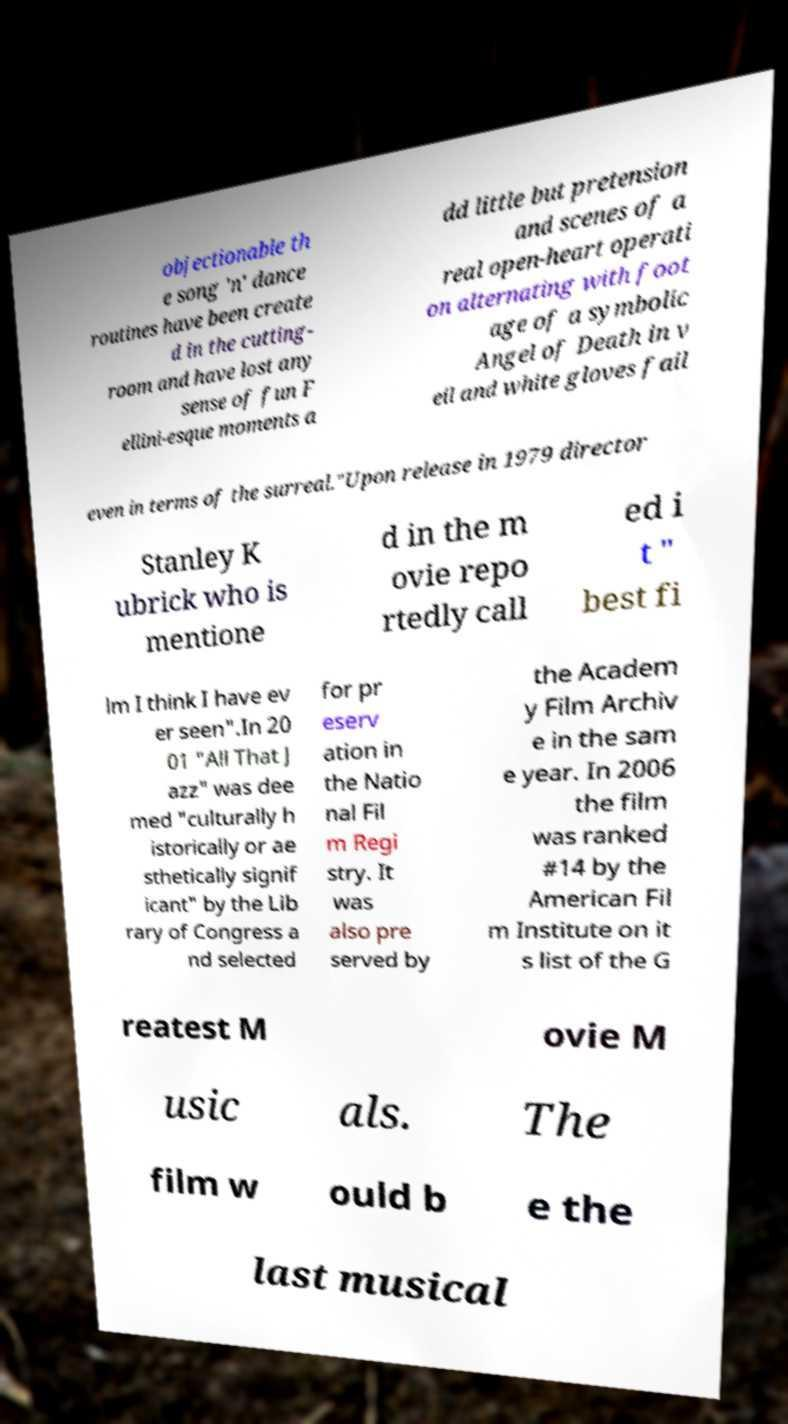Could you assist in decoding the text presented in this image and type it out clearly? objectionable th e song 'n' dance routines have been create d in the cutting- room and have lost any sense of fun F ellini-esque moments a dd little but pretension and scenes of a real open-heart operati on alternating with foot age of a symbolic Angel of Death in v eil and white gloves fail even in terms of the surreal."Upon release in 1979 director Stanley K ubrick who is mentione d in the m ovie repo rtedly call ed i t " best fi lm I think I have ev er seen".In 20 01 "All That J azz" was dee med "culturally h istorically or ae sthetically signif icant" by the Lib rary of Congress a nd selected for pr eserv ation in the Natio nal Fil m Regi stry. It was also pre served by the Academ y Film Archiv e in the sam e year. In 2006 the film was ranked #14 by the American Fil m Institute on it s list of the G reatest M ovie M usic als. The film w ould b e the last musical 